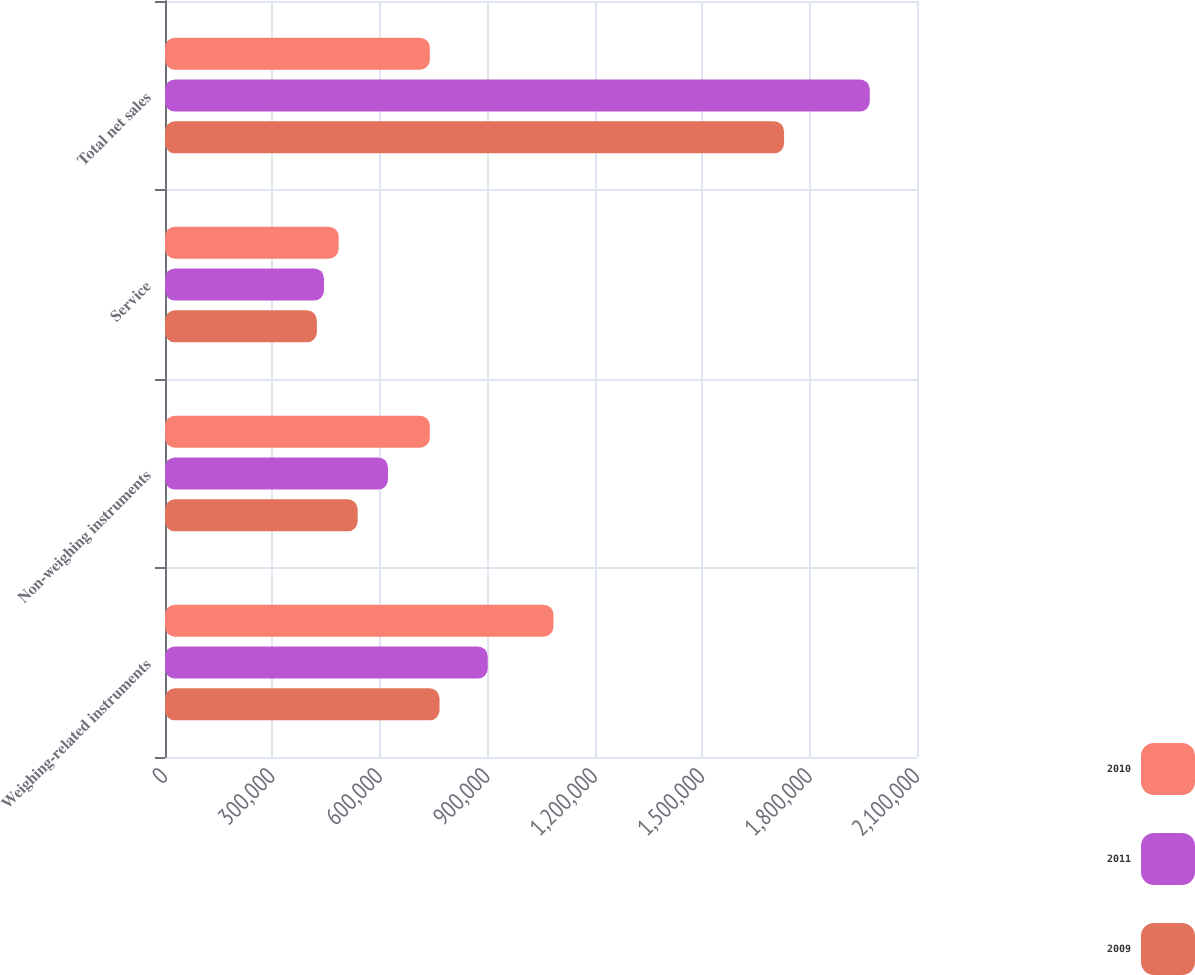<chart> <loc_0><loc_0><loc_500><loc_500><stacked_bar_chart><ecel><fcel>Weighing-related instruments<fcel>Non-weighing instruments<fcel>Service<fcel>Total net sales<nl><fcel>2010<fcel>1.08478e+06<fcel>739534<fcel>485018<fcel>739534<nl><fcel>2011<fcel>901285<fcel>622798<fcel>444095<fcel>1.96818e+06<nl><fcel>2009<fcel>766636<fcel>538077<fcel>424140<fcel>1.72885e+06<nl></chart> 